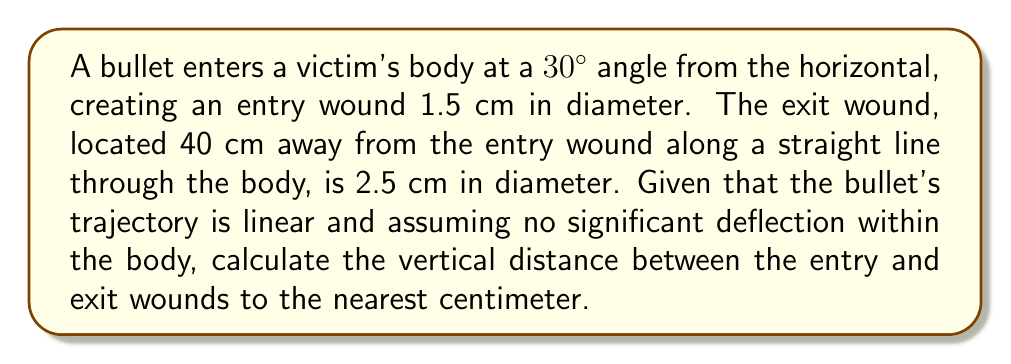What is the answer to this math problem? To solve this problem, we'll follow these steps:

1) First, let's visualize the trajectory as a right triangle, where:
   - The hypotenuse is the bullet's path (40 cm)
   - The angle with the horizontal is 30°
   - We need to find the opposite side (vertical distance)

2) We can use the sine function to find the vertical distance:

   $\sin(\theta) = \frac{\text{opposite}}{\text{hypotenuse}}$

3) Substituting our known values:

   $\sin(30°) = \frac{\text{vertical distance}}{40 \text{ cm}}$

4) We know that $\sin(30°) = \frac{1}{2}$, so:

   $\frac{1}{2} = \frac{\text{vertical distance}}{40 \text{ cm}}$

5) Solving for the vertical distance:

   $\text{vertical distance} = 40 \text{ cm} \times \frac{1}{2} = 20 \text{ cm}$

6) The question asks for the answer to the nearest centimeter, so our final answer is 20 cm.

Note: The difference in wound diameters (entry 1.5 cm, exit 2.5 cm) supports the calculated trajectory, as bullets typically create larger exit wounds due to tumbling and deformation. This detail, while not directly used in the calculation, would be important for a meticulous pathologist to note and could help confirm the trajectory analysis.
Answer: 20 cm 